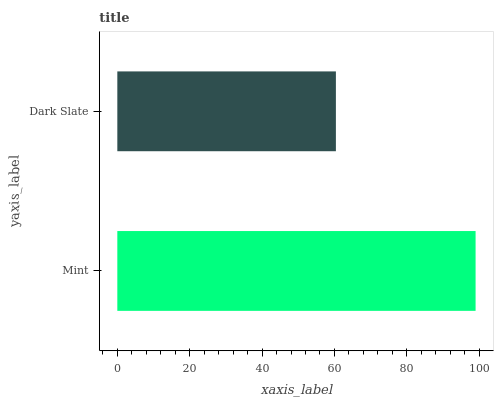Is Dark Slate the minimum?
Answer yes or no. Yes. Is Mint the maximum?
Answer yes or no. Yes. Is Dark Slate the maximum?
Answer yes or no. No. Is Mint greater than Dark Slate?
Answer yes or no. Yes. Is Dark Slate less than Mint?
Answer yes or no. Yes. Is Dark Slate greater than Mint?
Answer yes or no. No. Is Mint less than Dark Slate?
Answer yes or no. No. Is Mint the high median?
Answer yes or no. Yes. Is Dark Slate the low median?
Answer yes or no. Yes. Is Dark Slate the high median?
Answer yes or no. No. Is Mint the low median?
Answer yes or no. No. 